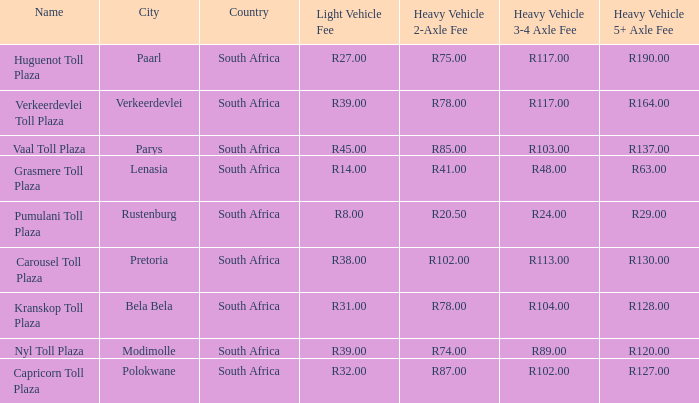What is the name of the plaza where the toll for heavy vehicles with 2 axles is r87.00? Capricorn Toll Plaza. 